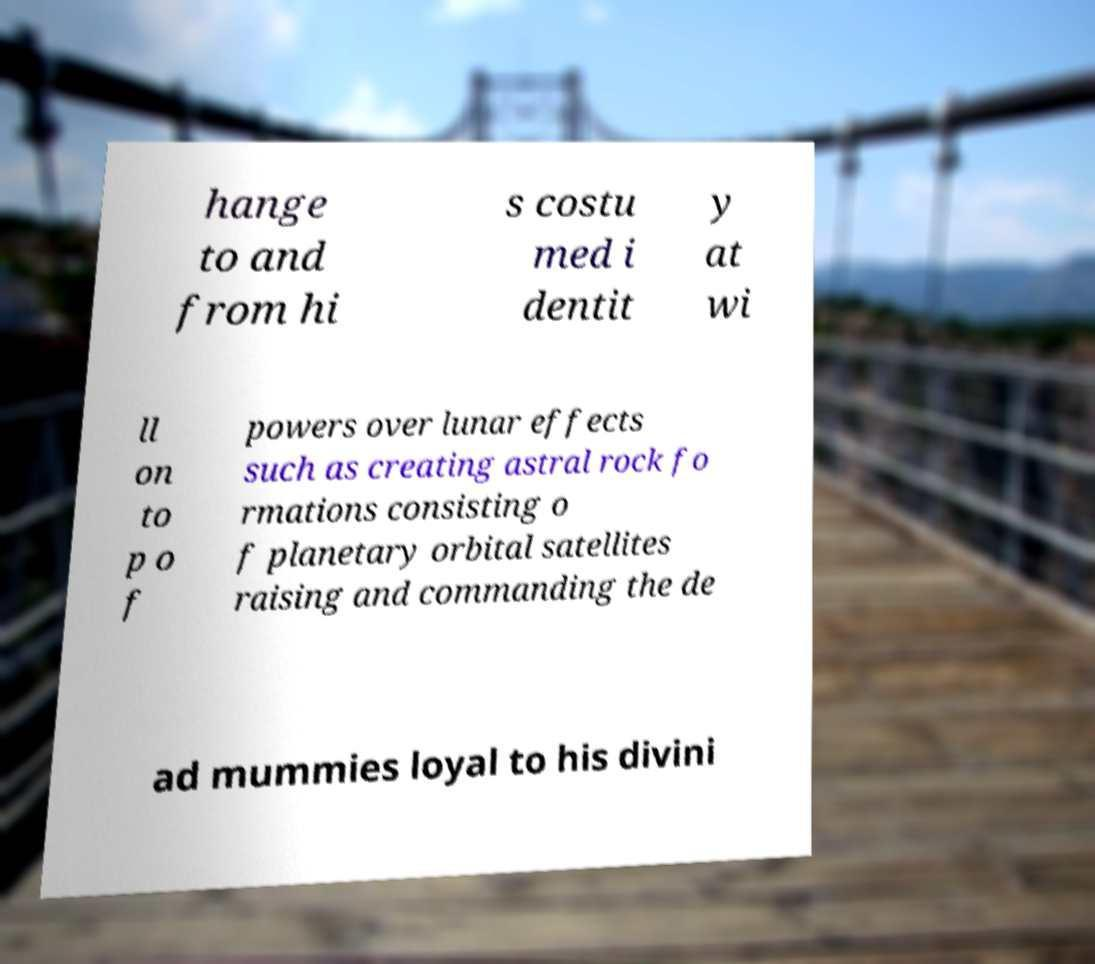Can you accurately transcribe the text from the provided image for me? hange to and from hi s costu med i dentit y at wi ll on to p o f powers over lunar effects such as creating astral rock fo rmations consisting o f planetary orbital satellites raising and commanding the de ad mummies loyal to his divini 